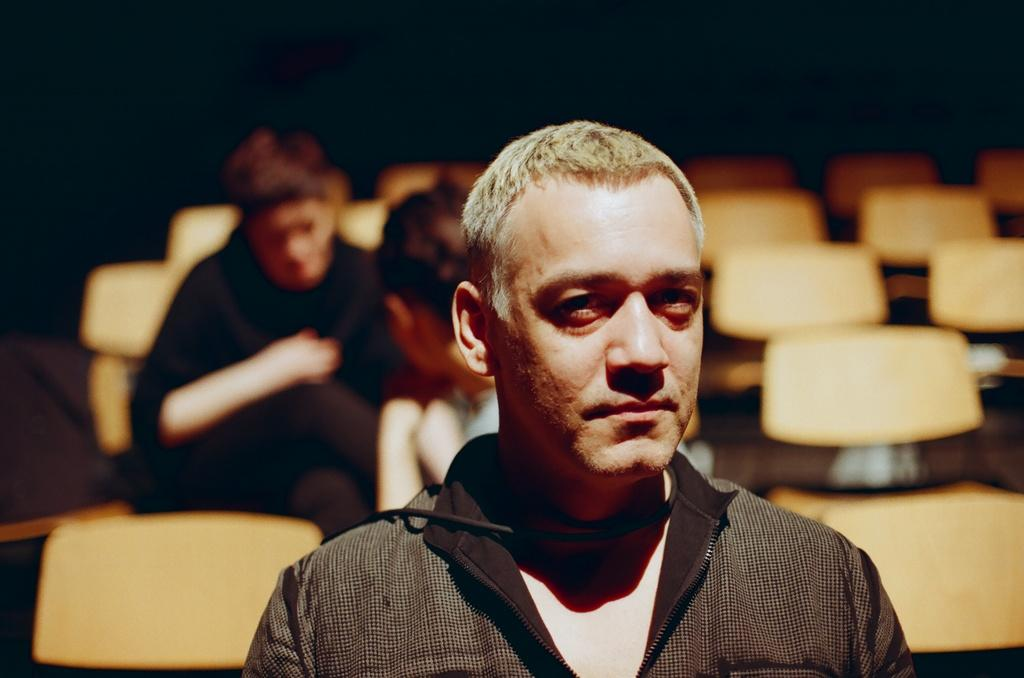Who or what can be seen in the image? There are people in the image. What are the people doing in the image? The people are sitting on chairs. What type of wound can be seen on the person's hand in the image? There is no wound visible on anyone's hand in the image. 